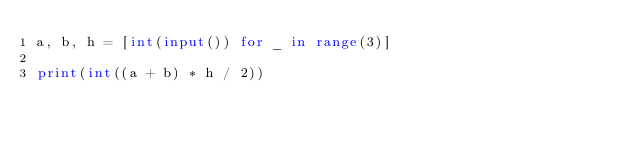<code> <loc_0><loc_0><loc_500><loc_500><_Python_>a, b, h = [int(input()) for _ in range(3)]
 
print(int((a + b) * h / 2))
</code> 